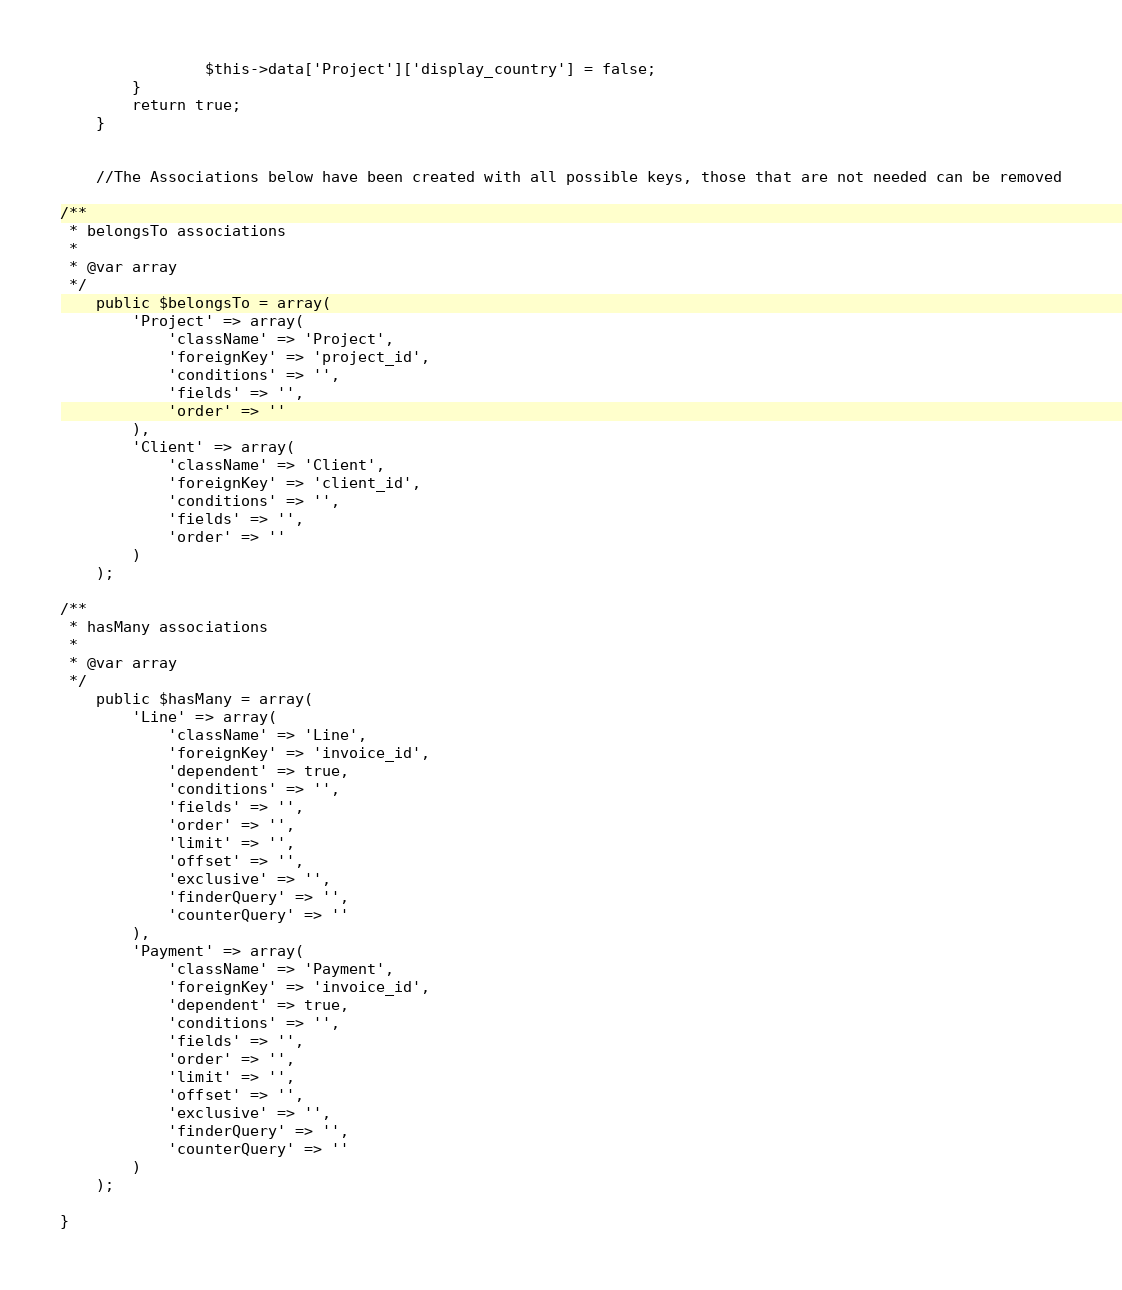<code> <loc_0><loc_0><loc_500><loc_500><_PHP_>				$this->data['Project']['display_country'] = false;
		}
		return true;
	}


	//The Associations below have been created with all possible keys, those that are not needed can be removed

/**
 * belongsTo associations
 *
 * @var array
 */
	public $belongsTo = array(
		'Project' => array(
			'className' => 'Project',
			'foreignKey' => 'project_id',
			'conditions' => '',
			'fields' => '',
			'order' => ''
		),
		'Client' => array(
			'className' => 'Client',
			'foreignKey' => 'client_id',
			'conditions' => '',
			'fields' => '',
			'order' => ''
		)
	);

/**
 * hasMany associations
 *
 * @var array
 */
	public $hasMany = array(
		'Line' => array(
			'className' => 'Line',
			'foreignKey' => 'invoice_id',
			'dependent' => true,
			'conditions' => '',
			'fields' => '',
			'order' => '',
			'limit' => '',
			'offset' => '',
			'exclusive' => '',
			'finderQuery' => '',
			'counterQuery' => ''
		),
		'Payment' => array(
			'className' => 'Payment',
			'foreignKey' => 'invoice_id',
			'dependent' => true,
			'conditions' => '',
			'fields' => '',
			'order' => '',
			'limit' => '',
			'offset' => '',
			'exclusive' => '',
			'finderQuery' => '',
			'counterQuery' => ''
		)
	);

}
</code> 